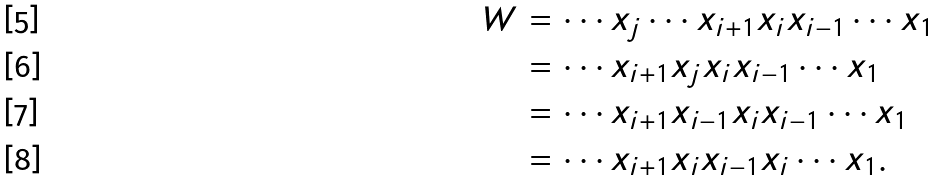<formula> <loc_0><loc_0><loc_500><loc_500>W & = \cdots x _ { j } \cdots x _ { i + 1 } x _ { i } x _ { i - 1 } \cdots x _ { 1 } \quad \\ & = \cdots x _ { i + 1 } x _ { j } x _ { i } x _ { i - 1 } \cdots x _ { 1 } \\ & = \cdots x _ { i + 1 } x _ { i - 1 } x _ { i } x _ { i - 1 } \cdots x _ { 1 } \\ & = \cdots x _ { i + 1 } x _ { i } x _ { i - 1 } x _ { i } \cdots x _ { 1 } .</formula> 